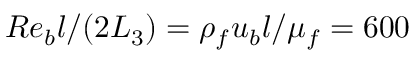<formula> <loc_0><loc_0><loc_500><loc_500>R e _ { b } l / ( 2 L _ { 3 } ) = \rho _ { f } u _ { b } l / \mu _ { f } = 6 0 0</formula> 